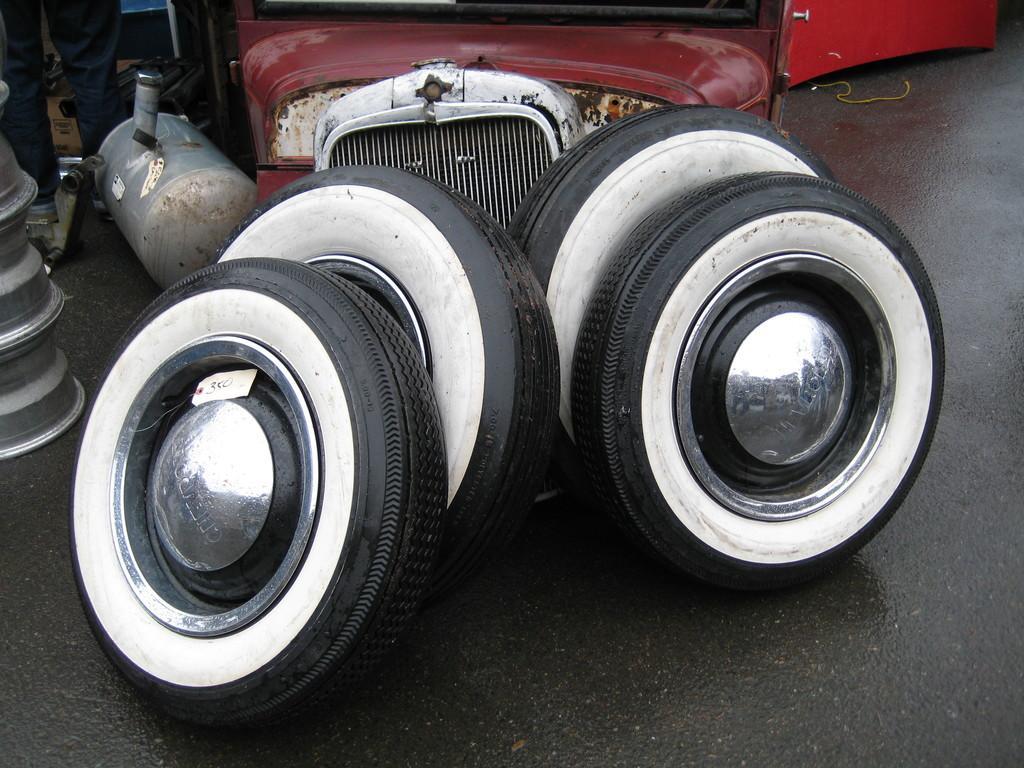Please provide a concise description of this image. In this picture there are four tires which are kept near to the bonnet. On the left we can see the steel panels. At the top left corner there is a man who is standing near to the cotton boxes. On the top right corner there is a car's door. 